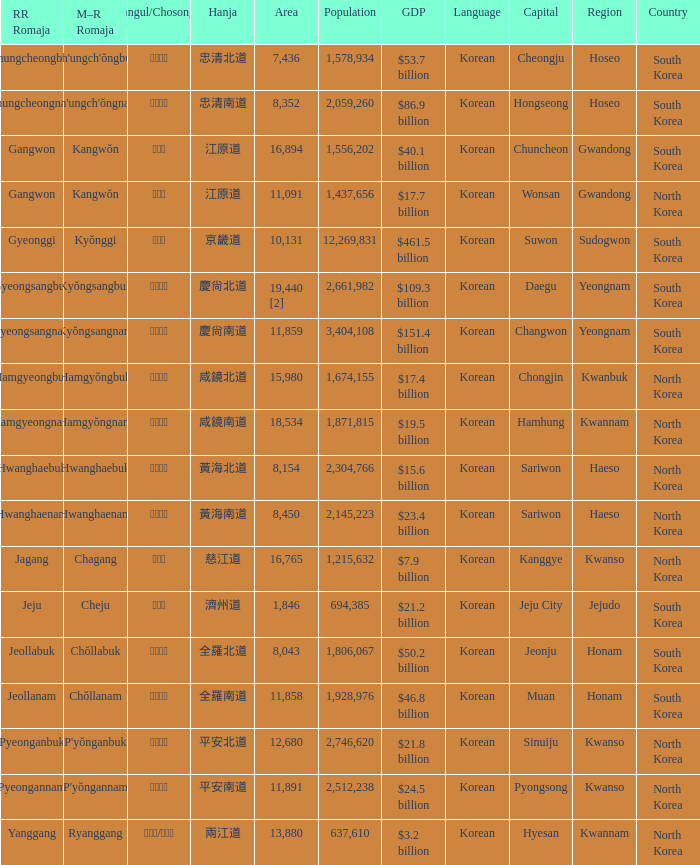Which country has a city with a Hanja of 平安北道? North Korea. 